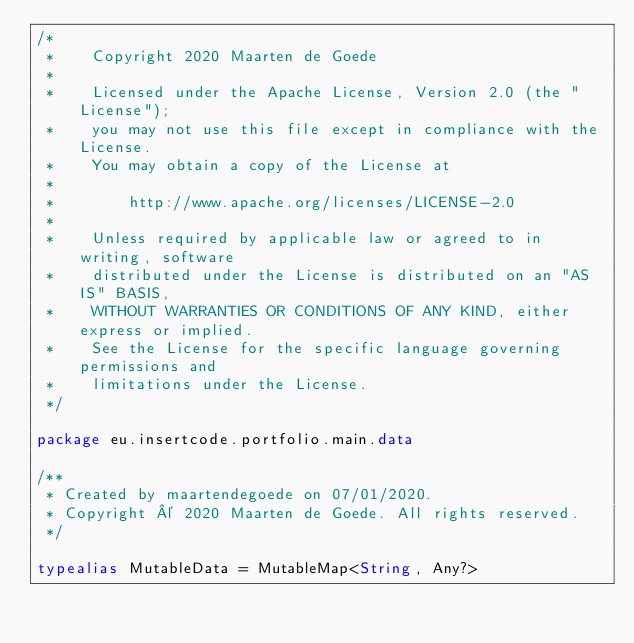Convert code to text. <code><loc_0><loc_0><loc_500><loc_500><_Kotlin_>/*
 *    Copyright 2020 Maarten de Goede
 *
 *    Licensed under the Apache License, Version 2.0 (the "License");
 *    you may not use this file except in compliance with the License.
 *    You may obtain a copy of the License at
 *
 *        http://www.apache.org/licenses/LICENSE-2.0
 *
 *    Unless required by applicable law or agreed to in writing, software
 *    distributed under the License is distributed on an "AS IS" BASIS,
 *    WITHOUT WARRANTIES OR CONDITIONS OF ANY KIND, either express or implied.
 *    See the License for the specific language governing permissions and
 *    limitations under the License.
 */

package eu.insertcode.portfolio.main.data

/**
 * Created by maartendegoede on 07/01/2020.
 * Copyright © 2020 Maarten de Goede. All rights reserved.
 */

typealias MutableData = MutableMap<String, Any?></code> 